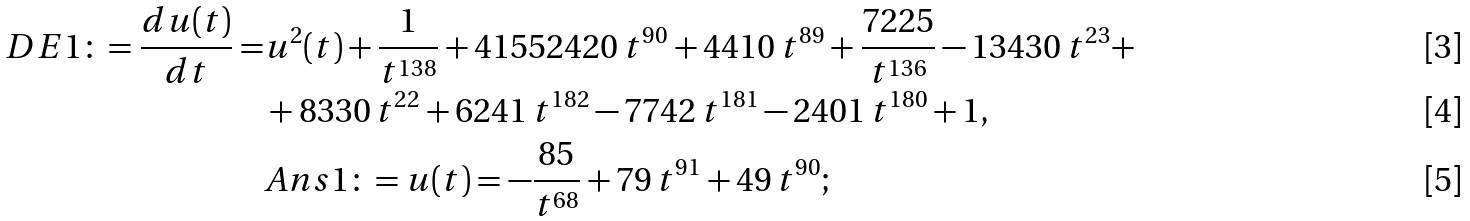<formula> <loc_0><loc_0><loc_500><loc_500>D E 1 \colon = \frac { d u ( t ) } { d t } = & u ^ { 2 } ( t ) + \frac { 1 } { t ^ { 1 3 8 } } + 4 1 5 5 2 4 2 0 \, t ^ { 9 0 } + 4 4 1 0 \, t ^ { 8 9 } + \frac { 7 2 2 5 } { t ^ { 1 3 6 } } - 1 3 4 3 0 \, t ^ { 2 3 } + \\ & + 8 3 3 0 \, t ^ { 2 2 } + 6 2 4 1 \, t ^ { 1 8 2 } - 7 7 4 2 \, t ^ { 1 8 1 } - 2 4 0 1 \, t ^ { 1 8 0 } + 1 , \\ & A n s 1 \colon = u ( t ) = - \frac { 8 5 } { t ^ { 6 8 } } + 7 9 \, t ^ { 9 1 } + 4 9 \, t ^ { 9 0 } ;</formula> 